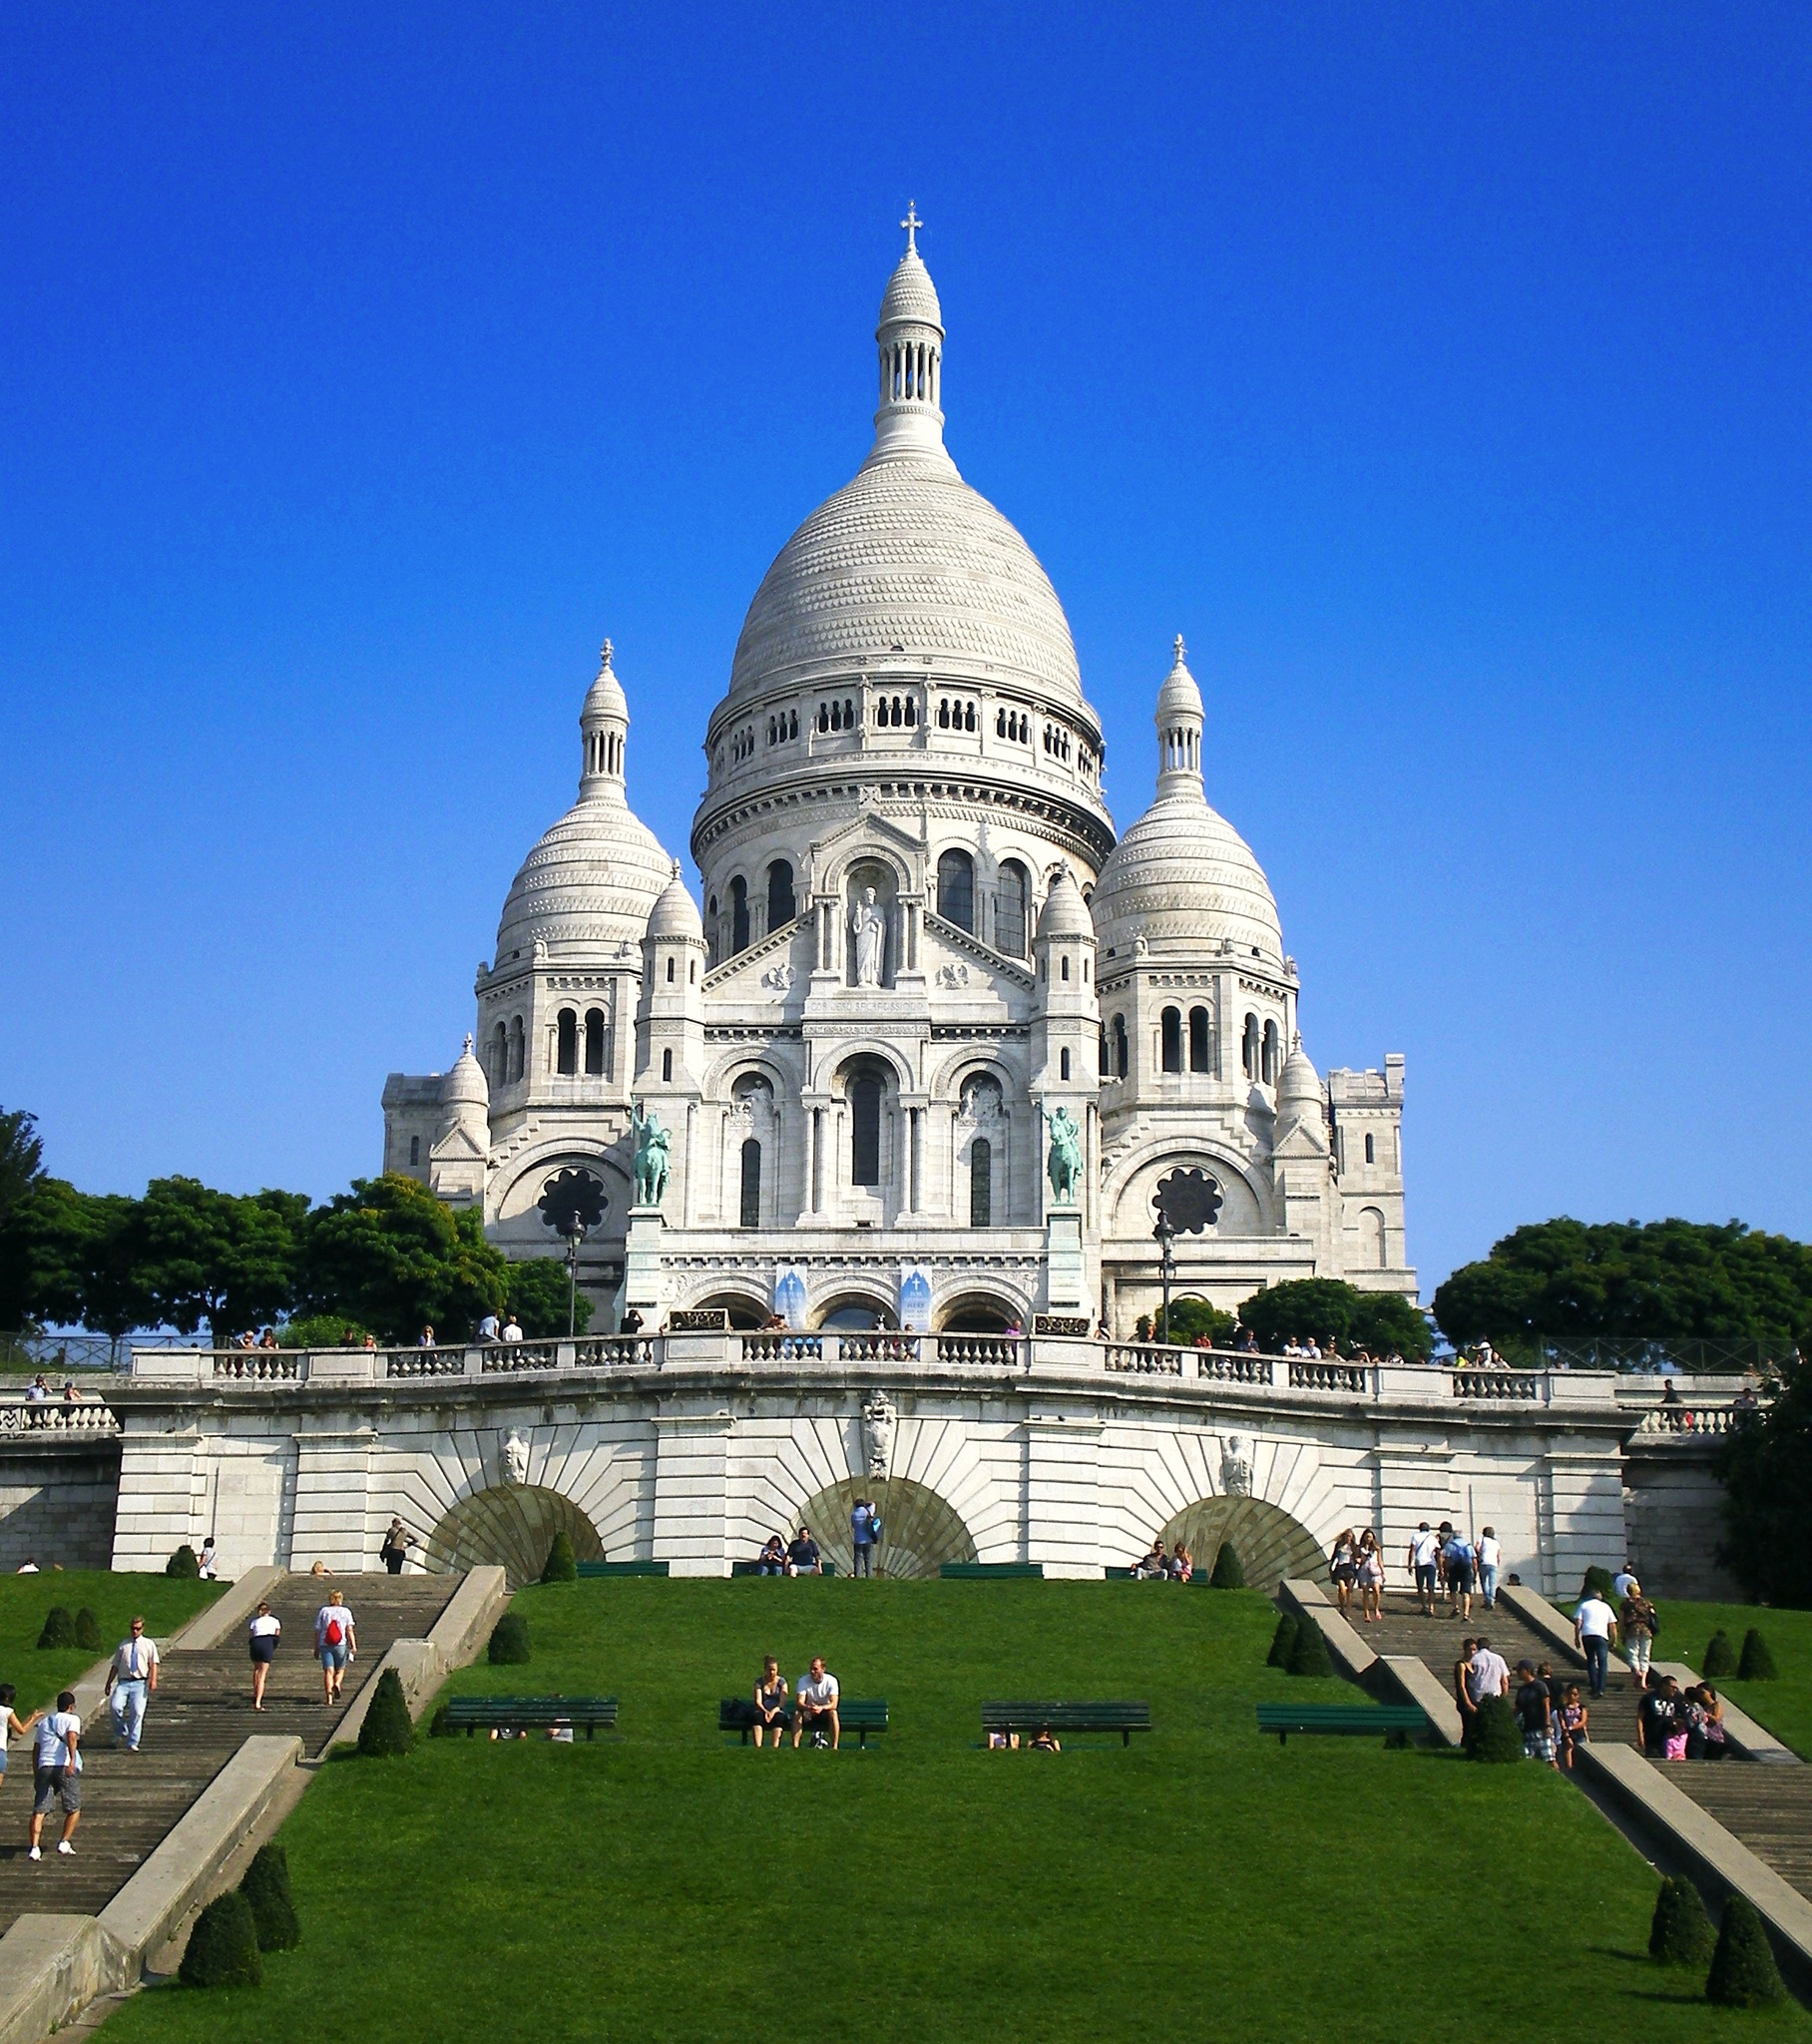What historical events has the Sacré-Cœur witnessed? The Sacré-Cœur has been a silent witness to a wide range of historical events since its completion in 1914, shortly after the end of the French Third Republic. It was built in memory of the French casualties of the Franco-Prussian War of 1870 and has since seen both World Wars. Its position atop Montmartre offers a symbolic watch over the city of Paris. During World War II, the area around Montmartre and the basilica itself were important sites for the French Resistance. 